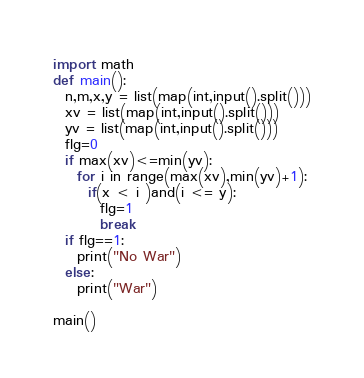Convert code to text. <code><loc_0><loc_0><loc_500><loc_500><_Python_>import math
def main():
  n,m,x,y = list(map(int,input().split()))
  xv = list(map(int,input().split()))
  yv = list(map(int,input().split()))
  flg=0
  if max(xv)<=min(yv):
    for i in range(max(xv),min(yv)+1):
      if(x < i )and(i <= y):
        flg=1
        break
  if flg==1:
    print("No War")
  else:
    print("War")

main()

</code> 